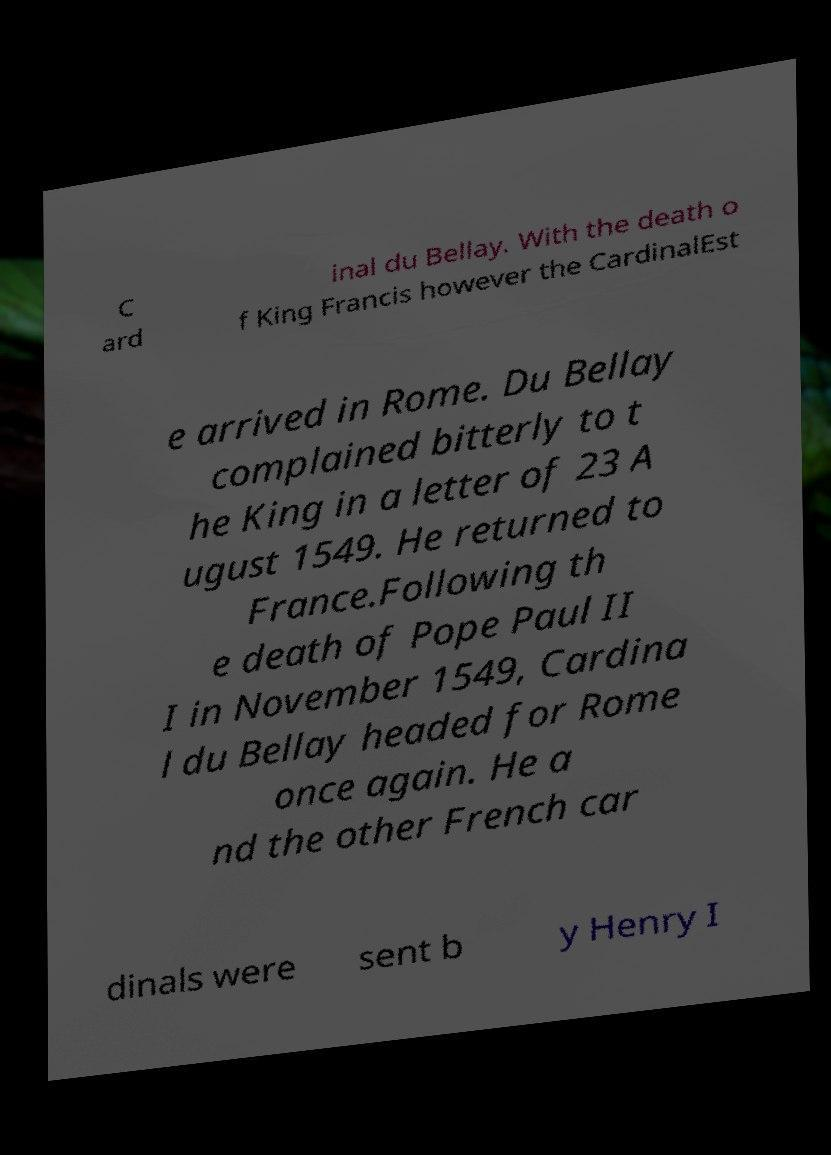I need the written content from this picture converted into text. Can you do that? C ard inal du Bellay. With the death o f King Francis however the CardinalEst e arrived in Rome. Du Bellay complained bitterly to t he King in a letter of 23 A ugust 1549. He returned to France.Following th e death of Pope Paul II I in November 1549, Cardina l du Bellay headed for Rome once again. He a nd the other French car dinals were sent b y Henry I 